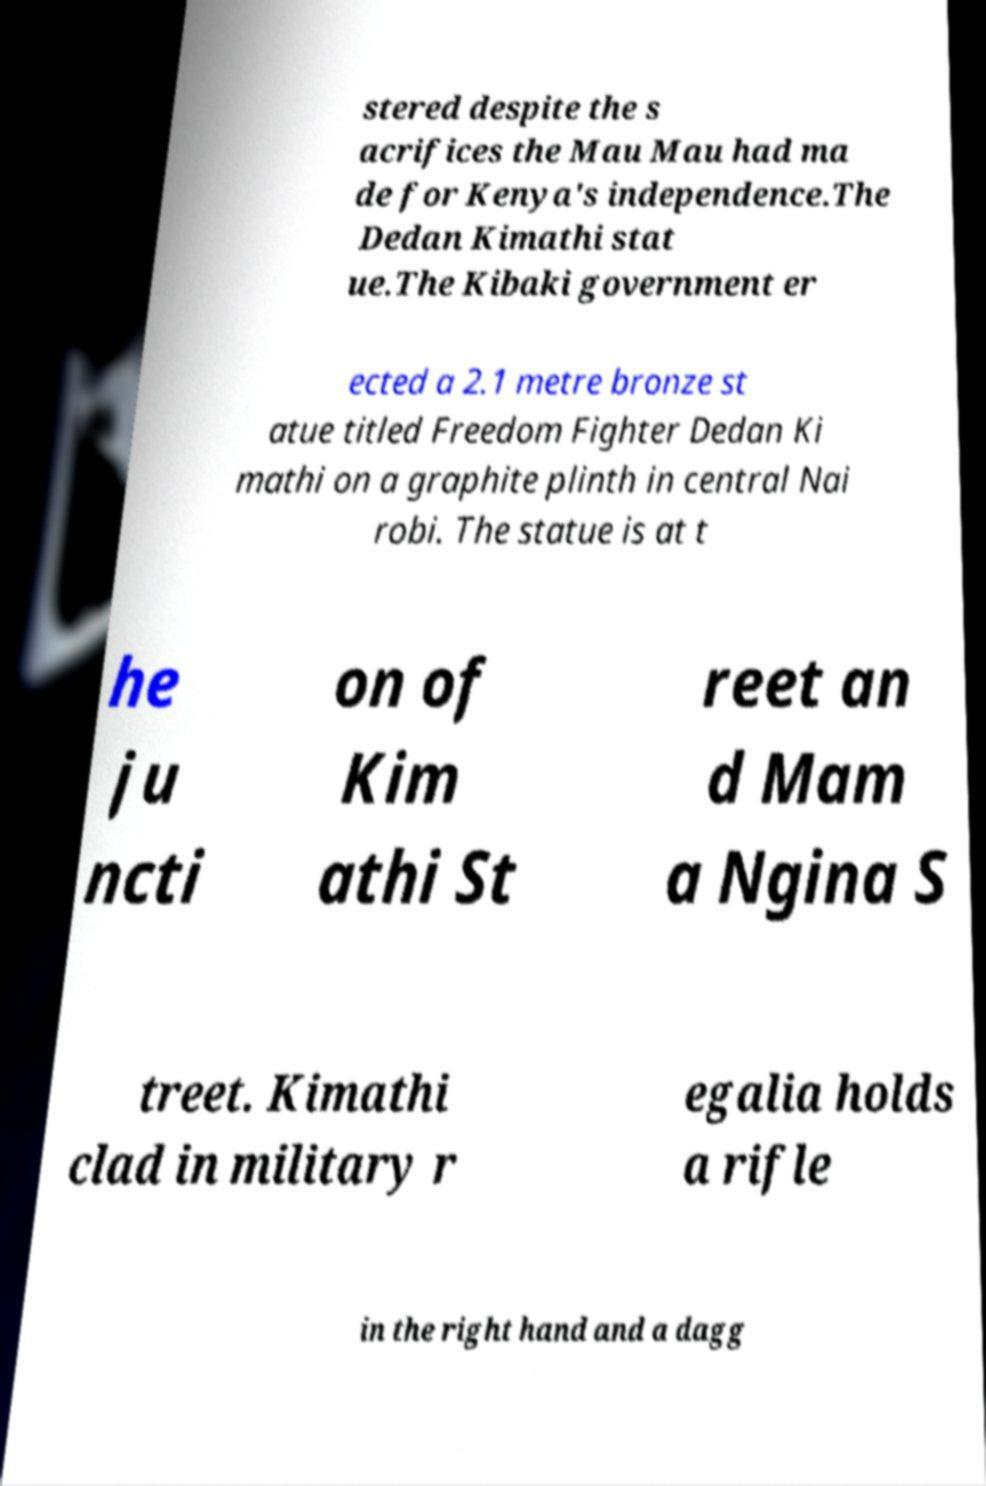Could you assist in decoding the text presented in this image and type it out clearly? stered despite the s acrifices the Mau Mau had ma de for Kenya's independence.The Dedan Kimathi stat ue.The Kibaki government er ected a 2.1 metre bronze st atue titled Freedom Fighter Dedan Ki mathi on a graphite plinth in central Nai robi. The statue is at t he ju ncti on of Kim athi St reet an d Mam a Ngina S treet. Kimathi clad in military r egalia holds a rifle in the right hand and a dagg 